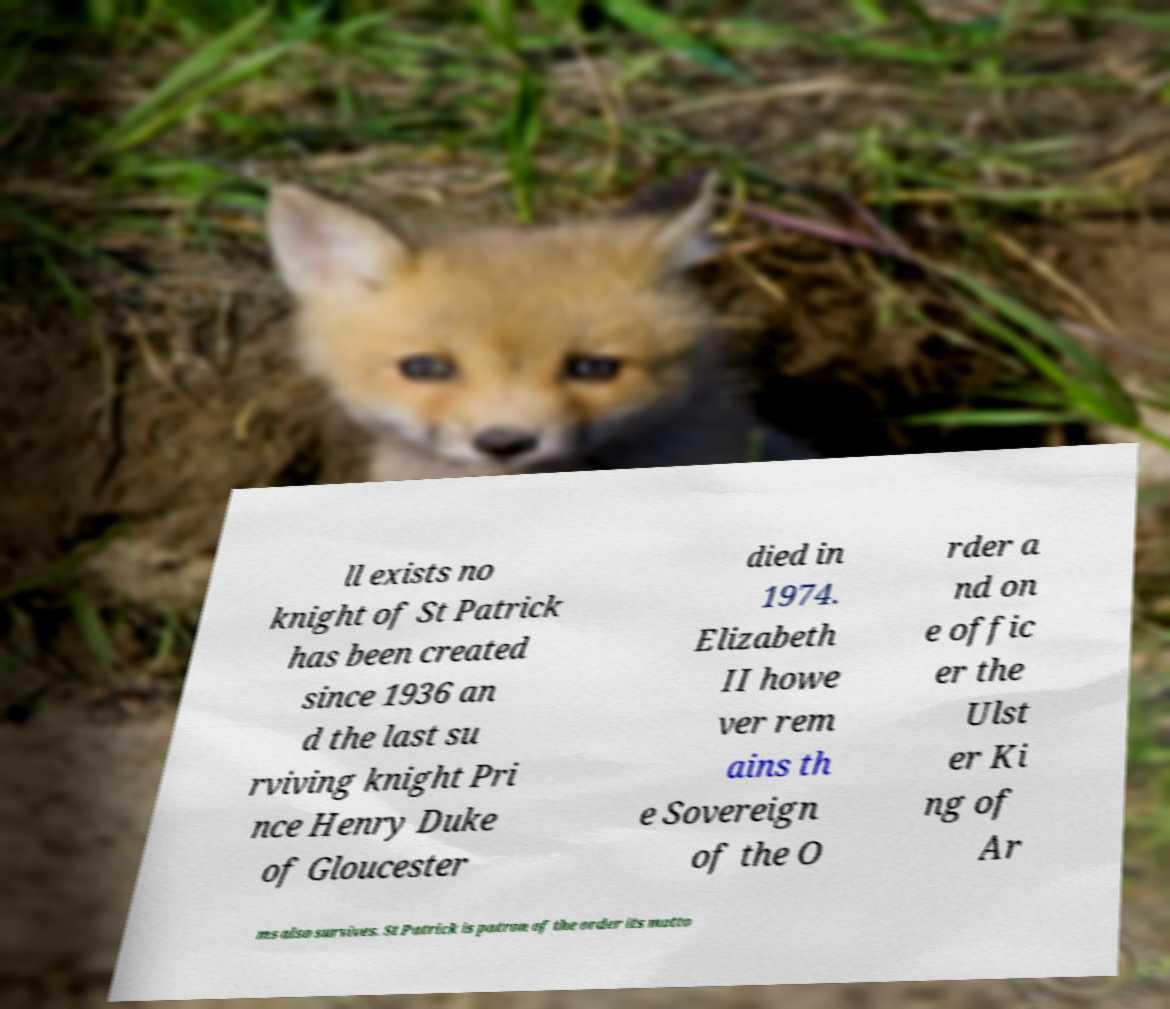Please read and relay the text visible in this image. What does it say? ll exists no knight of St Patrick has been created since 1936 an d the last su rviving knight Pri nce Henry Duke of Gloucester died in 1974. Elizabeth II howe ver rem ains th e Sovereign of the O rder a nd on e offic er the Ulst er Ki ng of Ar ms also survives. St Patrick is patron of the order its motto 